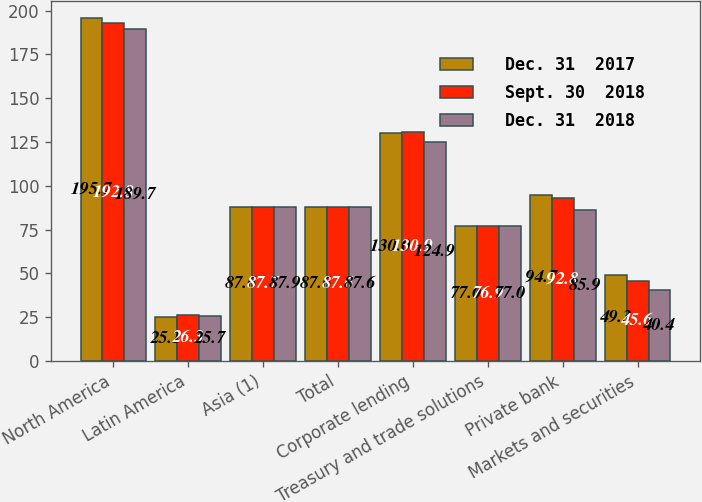<chart> <loc_0><loc_0><loc_500><loc_500><stacked_bar_chart><ecel><fcel>North America<fcel>Latin America<fcel>Asia (1)<fcel>Total<fcel>Corporate lending<fcel>Treasury and trade solutions<fcel>Private bank<fcel>Markets and securities<nl><fcel>Dec. 31  2017<fcel>195.7<fcel>25.1<fcel>87.6<fcel>87.6<fcel>130<fcel>77<fcel>94.7<fcel>49.3<nl><fcel>Sept. 30  2018<fcel>192.8<fcel>26.3<fcel>87.7<fcel>87.6<fcel>130.9<fcel>76.9<fcel>92.8<fcel>45.6<nl><fcel>Dec. 31  2018<fcel>189.7<fcel>25.7<fcel>87.9<fcel>87.6<fcel>124.9<fcel>77<fcel>85.9<fcel>40.4<nl></chart> 